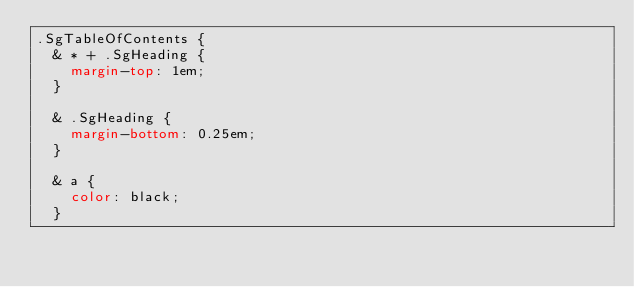<code> <loc_0><loc_0><loc_500><loc_500><_CSS_>.SgTableOfContents {
  & * + .SgHeading {
    margin-top: 1em;
  }

  & .SgHeading {
    margin-bottom: 0.25em;
  }

  & a {
    color: black;
  }
</code> 